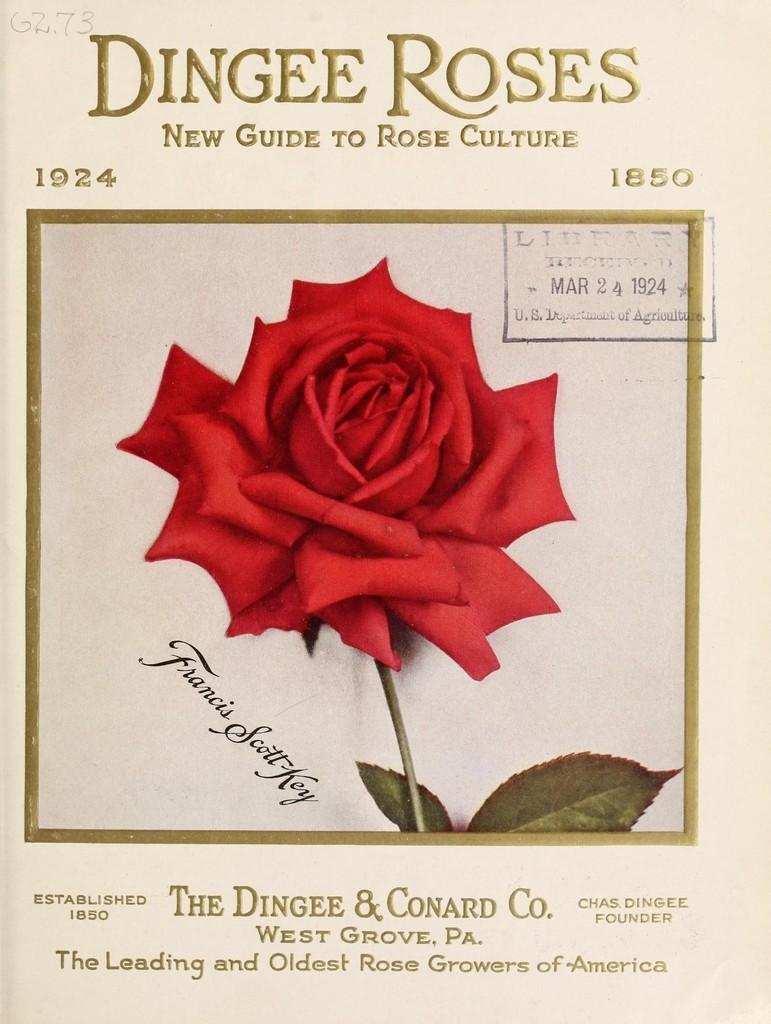Describe this image in one or two sentences. In this picture we can see the paper photo of the red rose. On the top we can see the "Dingee Roses" is written. 